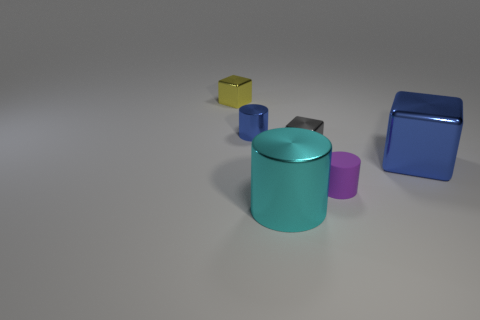Add 2 small blue cylinders. How many objects exist? 8 Add 3 small gray objects. How many small gray objects exist? 4 Subtract all purple cylinders. How many cylinders are left? 2 Subtract all tiny purple matte cylinders. How many cylinders are left? 2 Subtract 0 brown spheres. How many objects are left? 6 Subtract 2 cylinders. How many cylinders are left? 1 Subtract all brown cylinders. Subtract all yellow balls. How many cylinders are left? 3 Subtract all purple spheres. How many yellow cylinders are left? 0 Subtract all green metal blocks. Subtract all cyan objects. How many objects are left? 5 Add 2 gray blocks. How many gray blocks are left? 3 